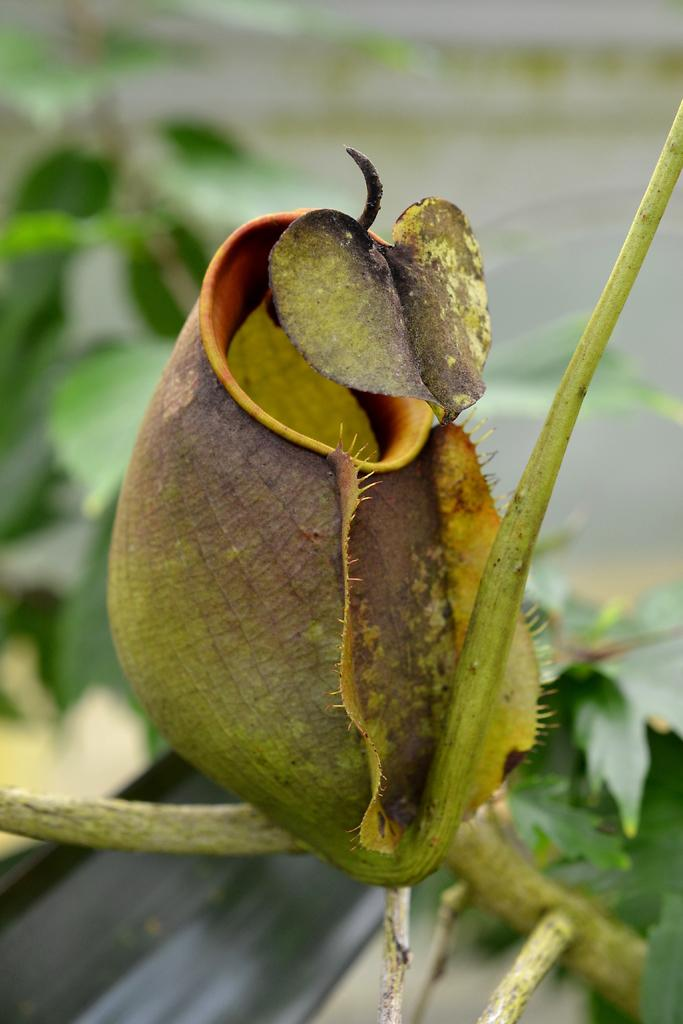What is the main subject of the image? The main subject of the image is a flower bud. How is the flower bud connected to the rest of the plant? The flower bud is attached to a stem. What other parts of the plant can be seen in the image? There are leaves in the image. Can you describe the background of the image? The background of the image appears blurry. What is the title of the book shown on the cover in the image? There is no book or cover present in the image; it features a flower bud and leaves. 